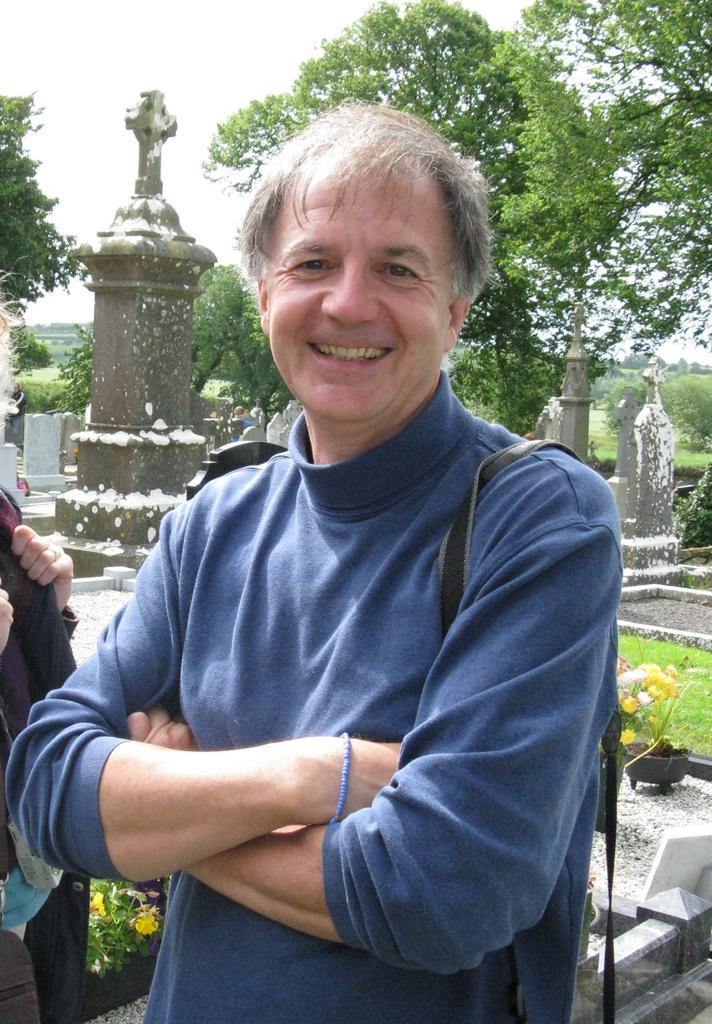In one or two sentences, can you explain what this image depicts? In this picture, we can see a few people, and we can see the ground, graves, plants, flowers, trees, and the sky. 